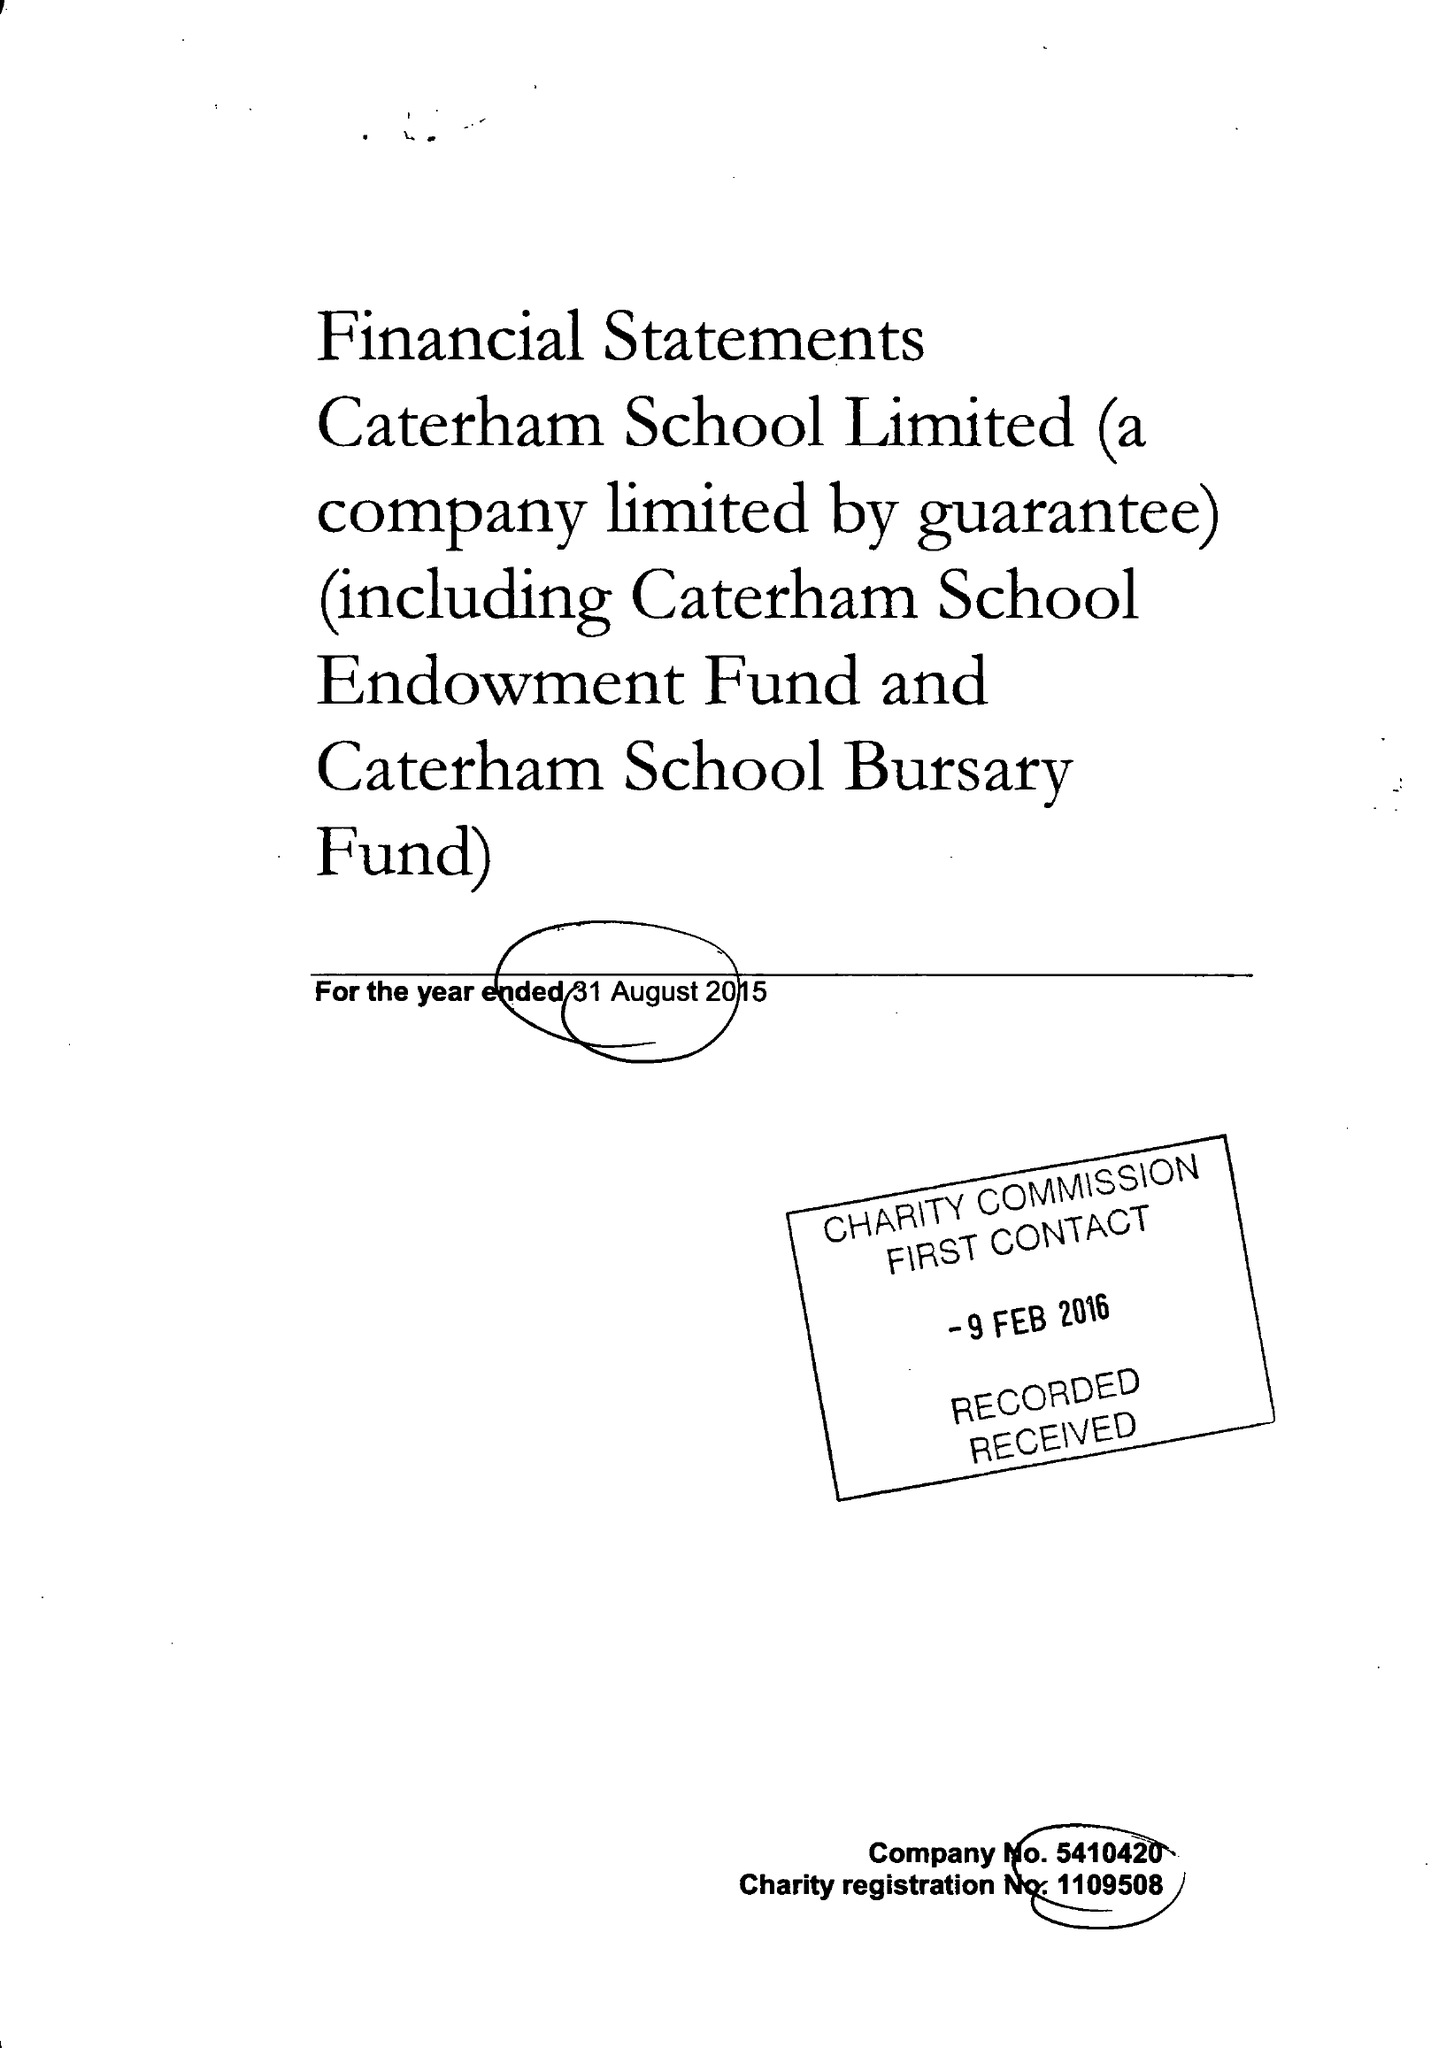What is the value for the income_annually_in_british_pounds?
Answer the question using a single word or phrase. 17925000.00 